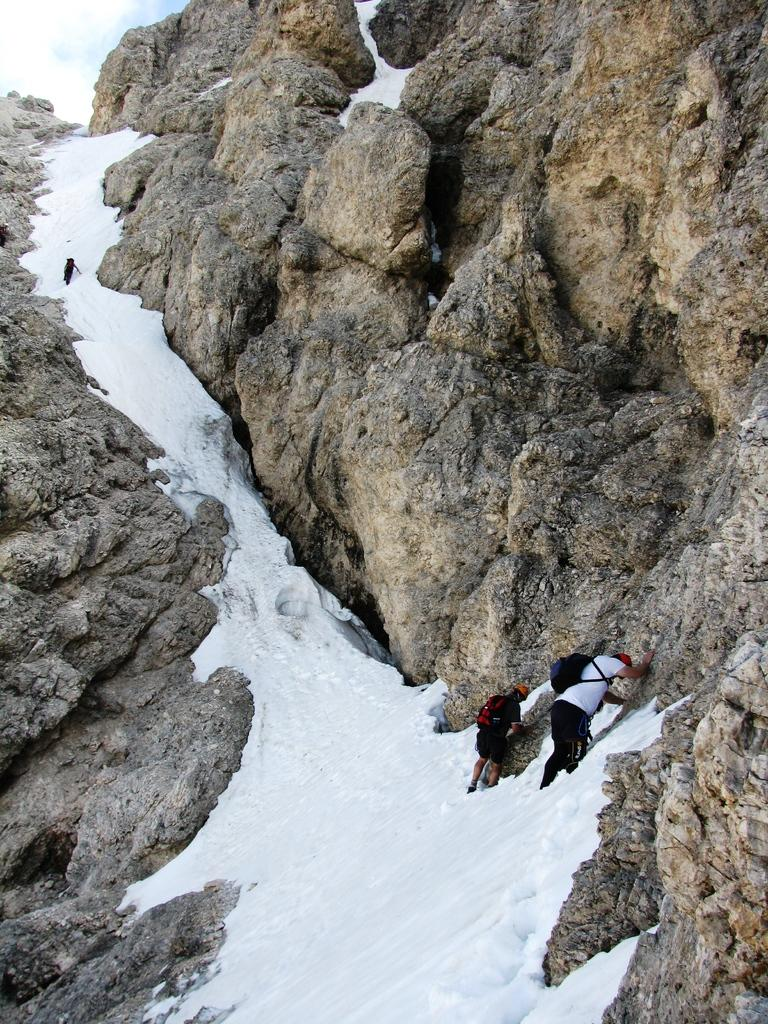What is the main subject of the image? The image depicts a hill. What are the three persons in the image doing? The three persons are climbing the hill. What can be seen at the top of the hill? The sky is visible at the top of the hill. What is the weather like in the image? The presence of clouds in the sky suggests that it might be partly cloudy. What is the condition of the hill's base? There is snow at the bottom of the hill. What type of agreement can be seen being signed at the top of the hill in the image? There is no agreement or signing activity depicted in the image; it features three persons climbing a hill with snow at the bottom and clouds in the sky. 